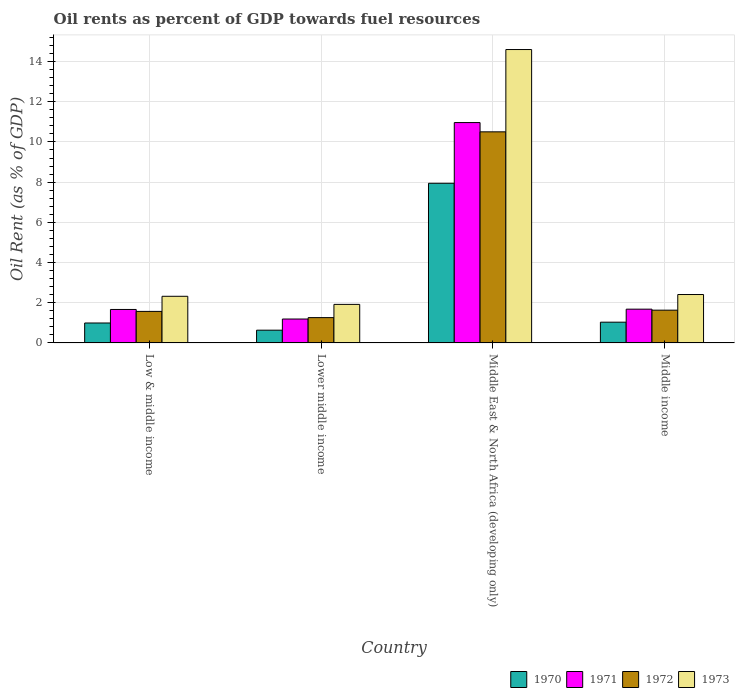How many different coloured bars are there?
Your response must be concise. 4. How many groups of bars are there?
Ensure brevity in your answer.  4. How many bars are there on the 4th tick from the left?
Provide a succinct answer. 4. What is the label of the 4th group of bars from the left?
Provide a short and direct response. Middle income. In how many cases, is the number of bars for a given country not equal to the number of legend labels?
Offer a very short reply. 0. What is the oil rent in 1972 in Lower middle income?
Provide a succinct answer. 1.26. Across all countries, what is the maximum oil rent in 1973?
Ensure brevity in your answer.  14.6. Across all countries, what is the minimum oil rent in 1973?
Ensure brevity in your answer.  1.92. In which country was the oil rent in 1973 maximum?
Your answer should be compact. Middle East & North Africa (developing only). In which country was the oil rent in 1971 minimum?
Offer a very short reply. Lower middle income. What is the total oil rent in 1971 in the graph?
Provide a short and direct response. 15.5. What is the difference between the oil rent in 1972 in Low & middle income and that in Middle East & North Africa (developing only)?
Ensure brevity in your answer.  -8.93. What is the difference between the oil rent in 1972 in Middle income and the oil rent in 1970 in Middle East & North Africa (developing only)?
Your response must be concise. -6.31. What is the average oil rent in 1973 per country?
Your answer should be very brief. 5.31. What is the difference between the oil rent of/in 1973 and oil rent of/in 1970 in Middle income?
Your answer should be very brief. 1.38. What is the ratio of the oil rent in 1970 in Lower middle income to that in Middle income?
Ensure brevity in your answer.  0.62. Is the oil rent in 1971 in Lower middle income less than that in Middle income?
Your answer should be very brief. Yes. Is the difference between the oil rent in 1973 in Lower middle income and Middle income greater than the difference between the oil rent in 1970 in Lower middle income and Middle income?
Offer a very short reply. No. What is the difference between the highest and the second highest oil rent in 1971?
Your response must be concise. -9.28. What is the difference between the highest and the lowest oil rent in 1973?
Offer a very short reply. 12.68. In how many countries, is the oil rent in 1973 greater than the average oil rent in 1973 taken over all countries?
Offer a terse response. 1. Is the sum of the oil rent in 1972 in Low & middle income and Middle income greater than the maximum oil rent in 1973 across all countries?
Give a very brief answer. No. What does the 4th bar from the right in Middle East & North Africa (developing only) represents?
Your answer should be compact. 1970. Is it the case that in every country, the sum of the oil rent in 1973 and oil rent in 1970 is greater than the oil rent in 1972?
Ensure brevity in your answer.  Yes. How many bars are there?
Make the answer very short. 16. What is the title of the graph?
Your answer should be very brief. Oil rents as percent of GDP towards fuel resources. Does "1963" appear as one of the legend labels in the graph?
Provide a succinct answer. No. What is the label or title of the X-axis?
Provide a short and direct response. Country. What is the label or title of the Y-axis?
Give a very brief answer. Oil Rent (as % of GDP). What is the Oil Rent (as % of GDP) of 1970 in Low & middle income?
Offer a very short reply. 0.99. What is the Oil Rent (as % of GDP) in 1971 in Low & middle income?
Keep it short and to the point. 1.67. What is the Oil Rent (as % of GDP) in 1972 in Low & middle income?
Your answer should be very brief. 1.57. What is the Oil Rent (as % of GDP) of 1973 in Low & middle income?
Offer a very short reply. 2.32. What is the Oil Rent (as % of GDP) of 1970 in Lower middle income?
Your answer should be compact. 0.63. What is the Oil Rent (as % of GDP) of 1971 in Lower middle income?
Your response must be concise. 1.19. What is the Oil Rent (as % of GDP) of 1972 in Lower middle income?
Keep it short and to the point. 1.26. What is the Oil Rent (as % of GDP) of 1973 in Lower middle income?
Your answer should be compact. 1.92. What is the Oil Rent (as % of GDP) in 1970 in Middle East & North Africa (developing only)?
Provide a short and direct response. 7.94. What is the Oil Rent (as % of GDP) of 1971 in Middle East & North Africa (developing only)?
Give a very brief answer. 10.96. What is the Oil Rent (as % of GDP) in 1972 in Middle East & North Africa (developing only)?
Your response must be concise. 10.5. What is the Oil Rent (as % of GDP) of 1973 in Middle East & North Africa (developing only)?
Your response must be concise. 14.6. What is the Oil Rent (as % of GDP) in 1970 in Middle income?
Ensure brevity in your answer.  1.03. What is the Oil Rent (as % of GDP) of 1971 in Middle income?
Give a very brief answer. 1.68. What is the Oil Rent (as % of GDP) of 1972 in Middle income?
Provide a short and direct response. 1.63. What is the Oil Rent (as % of GDP) in 1973 in Middle income?
Your response must be concise. 2.41. Across all countries, what is the maximum Oil Rent (as % of GDP) of 1970?
Provide a succinct answer. 7.94. Across all countries, what is the maximum Oil Rent (as % of GDP) in 1971?
Offer a very short reply. 10.96. Across all countries, what is the maximum Oil Rent (as % of GDP) of 1972?
Your response must be concise. 10.5. Across all countries, what is the maximum Oil Rent (as % of GDP) in 1973?
Your answer should be compact. 14.6. Across all countries, what is the minimum Oil Rent (as % of GDP) in 1970?
Offer a terse response. 0.63. Across all countries, what is the minimum Oil Rent (as % of GDP) in 1971?
Ensure brevity in your answer.  1.19. Across all countries, what is the minimum Oil Rent (as % of GDP) of 1972?
Your answer should be very brief. 1.26. Across all countries, what is the minimum Oil Rent (as % of GDP) of 1973?
Your response must be concise. 1.92. What is the total Oil Rent (as % of GDP) in 1970 in the graph?
Make the answer very short. 10.6. What is the total Oil Rent (as % of GDP) of 1971 in the graph?
Your answer should be very brief. 15.5. What is the total Oil Rent (as % of GDP) in 1972 in the graph?
Your response must be concise. 14.96. What is the total Oil Rent (as % of GDP) in 1973 in the graph?
Give a very brief answer. 21.24. What is the difference between the Oil Rent (as % of GDP) in 1970 in Low & middle income and that in Lower middle income?
Give a very brief answer. 0.36. What is the difference between the Oil Rent (as % of GDP) in 1971 in Low & middle income and that in Lower middle income?
Your answer should be compact. 0.48. What is the difference between the Oil Rent (as % of GDP) of 1972 in Low & middle income and that in Lower middle income?
Offer a very short reply. 0.31. What is the difference between the Oil Rent (as % of GDP) in 1973 in Low & middle income and that in Lower middle income?
Ensure brevity in your answer.  0.4. What is the difference between the Oil Rent (as % of GDP) in 1970 in Low & middle income and that in Middle East & North Africa (developing only)?
Provide a succinct answer. -6.95. What is the difference between the Oil Rent (as % of GDP) in 1971 in Low & middle income and that in Middle East & North Africa (developing only)?
Your answer should be very brief. -9.3. What is the difference between the Oil Rent (as % of GDP) of 1972 in Low & middle income and that in Middle East & North Africa (developing only)?
Your answer should be compact. -8.93. What is the difference between the Oil Rent (as % of GDP) of 1973 in Low & middle income and that in Middle East & North Africa (developing only)?
Offer a very short reply. -12.28. What is the difference between the Oil Rent (as % of GDP) in 1970 in Low & middle income and that in Middle income?
Keep it short and to the point. -0.04. What is the difference between the Oil Rent (as % of GDP) of 1971 in Low & middle income and that in Middle income?
Your answer should be very brief. -0.01. What is the difference between the Oil Rent (as % of GDP) of 1972 in Low & middle income and that in Middle income?
Your answer should be compact. -0.06. What is the difference between the Oil Rent (as % of GDP) of 1973 in Low & middle income and that in Middle income?
Keep it short and to the point. -0.09. What is the difference between the Oil Rent (as % of GDP) in 1970 in Lower middle income and that in Middle East & North Africa (developing only)?
Provide a short and direct response. -7.31. What is the difference between the Oil Rent (as % of GDP) of 1971 in Lower middle income and that in Middle East & North Africa (developing only)?
Ensure brevity in your answer.  -9.77. What is the difference between the Oil Rent (as % of GDP) of 1972 in Lower middle income and that in Middle East & North Africa (developing only)?
Your answer should be very brief. -9.24. What is the difference between the Oil Rent (as % of GDP) in 1973 in Lower middle income and that in Middle East & North Africa (developing only)?
Give a very brief answer. -12.68. What is the difference between the Oil Rent (as % of GDP) of 1970 in Lower middle income and that in Middle income?
Your response must be concise. -0.4. What is the difference between the Oil Rent (as % of GDP) of 1971 in Lower middle income and that in Middle income?
Your response must be concise. -0.49. What is the difference between the Oil Rent (as % of GDP) of 1972 in Lower middle income and that in Middle income?
Your answer should be compact. -0.37. What is the difference between the Oil Rent (as % of GDP) of 1973 in Lower middle income and that in Middle income?
Make the answer very short. -0.49. What is the difference between the Oil Rent (as % of GDP) in 1970 in Middle East & North Africa (developing only) and that in Middle income?
Make the answer very short. 6.91. What is the difference between the Oil Rent (as % of GDP) in 1971 in Middle East & North Africa (developing only) and that in Middle income?
Make the answer very short. 9.28. What is the difference between the Oil Rent (as % of GDP) in 1972 in Middle East & North Africa (developing only) and that in Middle income?
Keep it short and to the point. 8.87. What is the difference between the Oil Rent (as % of GDP) in 1973 in Middle East & North Africa (developing only) and that in Middle income?
Give a very brief answer. 12.19. What is the difference between the Oil Rent (as % of GDP) of 1970 in Low & middle income and the Oil Rent (as % of GDP) of 1971 in Lower middle income?
Ensure brevity in your answer.  -0.2. What is the difference between the Oil Rent (as % of GDP) of 1970 in Low & middle income and the Oil Rent (as % of GDP) of 1972 in Lower middle income?
Your answer should be compact. -0.27. What is the difference between the Oil Rent (as % of GDP) in 1970 in Low & middle income and the Oil Rent (as % of GDP) in 1973 in Lower middle income?
Offer a terse response. -0.93. What is the difference between the Oil Rent (as % of GDP) in 1971 in Low & middle income and the Oil Rent (as % of GDP) in 1972 in Lower middle income?
Your response must be concise. 0.41. What is the difference between the Oil Rent (as % of GDP) in 1971 in Low & middle income and the Oil Rent (as % of GDP) in 1973 in Lower middle income?
Make the answer very short. -0.25. What is the difference between the Oil Rent (as % of GDP) of 1972 in Low & middle income and the Oil Rent (as % of GDP) of 1973 in Lower middle income?
Your response must be concise. -0.35. What is the difference between the Oil Rent (as % of GDP) in 1970 in Low & middle income and the Oil Rent (as % of GDP) in 1971 in Middle East & North Africa (developing only)?
Your answer should be very brief. -9.97. What is the difference between the Oil Rent (as % of GDP) of 1970 in Low & middle income and the Oil Rent (as % of GDP) of 1972 in Middle East & North Africa (developing only)?
Offer a terse response. -9.51. What is the difference between the Oil Rent (as % of GDP) of 1970 in Low & middle income and the Oil Rent (as % of GDP) of 1973 in Middle East & North Africa (developing only)?
Your answer should be compact. -13.6. What is the difference between the Oil Rent (as % of GDP) of 1971 in Low & middle income and the Oil Rent (as % of GDP) of 1972 in Middle East & North Africa (developing only)?
Make the answer very short. -8.84. What is the difference between the Oil Rent (as % of GDP) of 1971 in Low & middle income and the Oil Rent (as % of GDP) of 1973 in Middle East & North Africa (developing only)?
Give a very brief answer. -12.93. What is the difference between the Oil Rent (as % of GDP) of 1972 in Low & middle income and the Oil Rent (as % of GDP) of 1973 in Middle East & North Africa (developing only)?
Your answer should be very brief. -13.03. What is the difference between the Oil Rent (as % of GDP) in 1970 in Low & middle income and the Oil Rent (as % of GDP) in 1971 in Middle income?
Ensure brevity in your answer.  -0.69. What is the difference between the Oil Rent (as % of GDP) of 1970 in Low & middle income and the Oil Rent (as % of GDP) of 1972 in Middle income?
Give a very brief answer. -0.64. What is the difference between the Oil Rent (as % of GDP) in 1970 in Low & middle income and the Oil Rent (as % of GDP) in 1973 in Middle income?
Your answer should be compact. -1.42. What is the difference between the Oil Rent (as % of GDP) of 1971 in Low & middle income and the Oil Rent (as % of GDP) of 1972 in Middle income?
Provide a short and direct response. 0.03. What is the difference between the Oil Rent (as % of GDP) of 1971 in Low & middle income and the Oil Rent (as % of GDP) of 1973 in Middle income?
Offer a terse response. -0.74. What is the difference between the Oil Rent (as % of GDP) in 1972 in Low & middle income and the Oil Rent (as % of GDP) in 1973 in Middle income?
Offer a very short reply. -0.84. What is the difference between the Oil Rent (as % of GDP) of 1970 in Lower middle income and the Oil Rent (as % of GDP) of 1971 in Middle East & North Africa (developing only)?
Ensure brevity in your answer.  -10.33. What is the difference between the Oil Rent (as % of GDP) in 1970 in Lower middle income and the Oil Rent (as % of GDP) in 1972 in Middle East & North Africa (developing only)?
Ensure brevity in your answer.  -9.87. What is the difference between the Oil Rent (as % of GDP) in 1970 in Lower middle income and the Oil Rent (as % of GDP) in 1973 in Middle East & North Africa (developing only)?
Give a very brief answer. -13.96. What is the difference between the Oil Rent (as % of GDP) of 1971 in Lower middle income and the Oil Rent (as % of GDP) of 1972 in Middle East & North Africa (developing only)?
Give a very brief answer. -9.31. What is the difference between the Oil Rent (as % of GDP) of 1971 in Lower middle income and the Oil Rent (as % of GDP) of 1973 in Middle East & North Africa (developing only)?
Give a very brief answer. -13.41. What is the difference between the Oil Rent (as % of GDP) of 1972 in Lower middle income and the Oil Rent (as % of GDP) of 1973 in Middle East & North Africa (developing only)?
Ensure brevity in your answer.  -13.34. What is the difference between the Oil Rent (as % of GDP) in 1970 in Lower middle income and the Oil Rent (as % of GDP) in 1971 in Middle income?
Ensure brevity in your answer.  -1.05. What is the difference between the Oil Rent (as % of GDP) in 1970 in Lower middle income and the Oil Rent (as % of GDP) in 1972 in Middle income?
Your response must be concise. -1. What is the difference between the Oil Rent (as % of GDP) in 1970 in Lower middle income and the Oil Rent (as % of GDP) in 1973 in Middle income?
Provide a succinct answer. -1.77. What is the difference between the Oil Rent (as % of GDP) in 1971 in Lower middle income and the Oil Rent (as % of GDP) in 1972 in Middle income?
Ensure brevity in your answer.  -0.44. What is the difference between the Oil Rent (as % of GDP) in 1971 in Lower middle income and the Oil Rent (as % of GDP) in 1973 in Middle income?
Offer a terse response. -1.22. What is the difference between the Oil Rent (as % of GDP) of 1972 in Lower middle income and the Oil Rent (as % of GDP) of 1973 in Middle income?
Your response must be concise. -1.15. What is the difference between the Oil Rent (as % of GDP) of 1970 in Middle East & North Africa (developing only) and the Oil Rent (as % of GDP) of 1971 in Middle income?
Your answer should be very brief. 6.26. What is the difference between the Oil Rent (as % of GDP) of 1970 in Middle East & North Africa (developing only) and the Oil Rent (as % of GDP) of 1972 in Middle income?
Offer a terse response. 6.31. What is the difference between the Oil Rent (as % of GDP) in 1970 in Middle East & North Africa (developing only) and the Oil Rent (as % of GDP) in 1973 in Middle income?
Offer a terse response. 5.53. What is the difference between the Oil Rent (as % of GDP) of 1971 in Middle East & North Africa (developing only) and the Oil Rent (as % of GDP) of 1972 in Middle income?
Offer a terse response. 9.33. What is the difference between the Oil Rent (as % of GDP) in 1971 in Middle East & North Africa (developing only) and the Oil Rent (as % of GDP) in 1973 in Middle income?
Your response must be concise. 8.55. What is the difference between the Oil Rent (as % of GDP) of 1972 in Middle East & North Africa (developing only) and the Oil Rent (as % of GDP) of 1973 in Middle income?
Ensure brevity in your answer.  8.09. What is the average Oil Rent (as % of GDP) of 1970 per country?
Offer a terse response. 2.65. What is the average Oil Rent (as % of GDP) of 1971 per country?
Offer a very short reply. 3.87. What is the average Oil Rent (as % of GDP) in 1972 per country?
Your answer should be compact. 3.74. What is the average Oil Rent (as % of GDP) in 1973 per country?
Make the answer very short. 5.31. What is the difference between the Oil Rent (as % of GDP) in 1970 and Oil Rent (as % of GDP) in 1971 in Low & middle income?
Provide a succinct answer. -0.67. What is the difference between the Oil Rent (as % of GDP) in 1970 and Oil Rent (as % of GDP) in 1972 in Low & middle income?
Keep it short and to the point. -0.58. What is the difference between the Oil Rent (as % of GDP) of 1970 and Oil Rent (as % of GDP) of 1973 in Low & middle income?
Your answer should be compact. -1.33. What is the difference between the Oil Rent (as % of GDP) in 1971 and Oil Rent (as % of GDP) in 1972 in Low & middle income?
Give a very brief answer. 0.1. What is the difference between the Oil Rent (as % of GDP) in 1971 and Oil Rent (as % of GDP) in 1973 in Low & middle income?
Your response must be concise. -0.66. What is the difference between the Oil Rent (as % of GDP) of 1972 and Oil Rent (as % of GDP) of 1973 in Low & middle income?
Ensure brevity in your answer.  -0.75. What is the difference between the Oil Rent (as % of GDP) in 1970 and Oil Rent (as % of GDP) in 1971 in Lower middle income?
Make the answer very short. -0.56. What is the difference between the Oil Rent (as % of GDP) in 1970 and Oil Rent (as % of GDP) in 1972 in Lower middle income?
Keep it short and to the point. -0.62. What is the difference between the Oil Rent (as % of GDP) of 1970 and Oil Rent (as % of GDP) of 1973 in Lower middle income?
Provide a short and direct response. -1.28. What is the difference between the Oil Rent (as % of GDP) of 1971 and Oil Rent (as % of GDP) of 1972 in Lower middle income?
Provide a short and direct response. -0.07. What is the difference between the Oil Rent (as % of GDP) in 1971 and Oil Rent (as % of GDP) in 1973 in Lower middle income?
Provide a short and direct response. -0.73. What is the difference between the Oil Rent (as % of GDP) in 1972 and Oil Rent (as % of GDP) in 1973 in Lower middle income?
Offer a very short reply. -0.66. What is the difference between the Oil Rent (as % of GDP) of 1970 and Oil Rent (as % of GDP) of 1971 in Middle East & North Africa (developing only)?
Give a very brief answer. -3.02. What is the difference between the Oil Rent (as % of GDP) in 1970 and Oil Rent (as % of GDP) in 1972 in Middle East & North Africa (developing only)?
Your answer should be very brief. -2.56. What is the difference between the Oil Rent (as % of GDP) in 1970 and Oil Rent (as % of GDP) in 1973 in Middle East & North Africa (developing only)?
Your answer should be very brief. -6.65. What is the difference between the Oil Rent (as % of GDP) in 1971 and Oil Rent (as % of GDP) in 1972 in Middle East & North Africa (developing only)?
Your answer should be compact. 0.46. What is the difference between the Oil Rent (as % of GDP) of 1971 and Oil Rent (as % of GDP) of 1973 in Middle East & North Africa (developing only)?
Your answer should be very brief. -3.63. What is the difference between the Oil Rent (as % of GDP) of 1972 and Oil Rent (as % of GDP) of 1973 in Middle East & North Africa (developing only)?
Your answer should be compact. -4.09. What is the difference between the Oil Rent (as % of GDP) in 1970 and Oil Rent (as % of GDP) in 1971 in Middle income?
Make the answer very short. -0.65. What is the difference between the Oil Rent (as % of GDP) of 1970 and Oil Rent (as % of GDP) of 1972 in Middle income?
Make the answer very short. -0.6. What is the difference between the Oil Rent (as % of GDP) in 1970 and Oil Rent (as % of GDP) in 1973 in Middle income?
Ensure brevity in your answer.  -1.38. What is the difference between the Oil Rent (as % of GDP) of 1971 and Oil Rent (as % of GDP) of 1972 in Middle income?
Offer a very short reply. 0.05. What is the difference between the Oil Rent (as % of GDP) in 1971 and Oil Rent (as % of GDP) in 1973 in Middle income?
Your response must be concise. -0.73. What is the difference between the Oil Rent (as % of GDP) in 1972 and Oil Rent (as % of GDP) in 1973 in Middle income?
Keep it short and to the point. -0.78. What is the ratio of the Oil Rent (as % of GDP) of 1970 in Low & middle income to that in Lower middle income?
Give a very brief answer. 1.56. What is the ratio of the Oil Rent (as % of GDP) in 1971 in Low & middle income to that in Lower middle income?
Keep it short and to the point. 1.4. What is the ratio of the Oil Rent (as % of GDP) of 1972 in Low & middle income to that in Lower middle income?
Provide a short and direct response. 1.25. What is the ratio of the Oil Rent (as % of GDP) in 1973 in Low & middle income to that in Lower middle income?
Ensure brevity in your answer.  1.21. What is the ratio of the Oil Rent (as % of GDP) in 1970 in Low & middle income to that in Middle East & North Africa (developing only)?
Offer a terse response. 0.12. What is the ratio of the Oil Rent (as % of GDP) in 1971 in Low & middle income to that in Middle East & North Africa (developing only)?
Offer a terse response. 0.15. What is the ratio of the Oil Rent (as % of GDP) in 1972 in Low & middle income to that in Middle East & North Africa (developing only)?
Your response must be concise. 0.15. What is the ratio of the Oil Rent (as % of GDP) in 1973 in Low & middle income to that in Middle East & North Africa (developing only)?
Your answer should be very brief. 0.16. What is the ratio of the Oil Rent (as % of GDP) in 1971 in Low & middle income to that in Middle income?
Give a very brief answer. 0.99. What is the ratio of the Oil Rent (as % of GDP) of 1972 in Low & middle income to that in Middle income?
Your answer should be very brief. 0.96. What is the ratio of the Oil Rent (as % of GDP) of 1973 in Low & middle income to that in Middle income?
Keep it short and to the point. 0.96. What is the ratio of the Oil Rent (as % of GDP) in 1970 in Lower middle income to that in Middle East & North Africa (developing only)?
Provide a short and direct response. 0.08. What is the ratio of the Oil Rent (as % of GDP) in 1971 in Lower middle income to that in Middle East & North Africa (developing only)?
Your response must be concise. 0.11. What is the ratio of the Oil Rent (as % of GDP) in 1972 in Lower middle income to that in Middle East & North Africa (developing only)?
Make the answer very short. 0.12. What is the ratio of the Oil Rent (as % of GDP) in 1973 in Lower middle income to that in Middle East & North Africa (developing only)?
Ensure brevity in your answer.  0.13. What is the ratio of the Oil Rent (as % of GDP) in 1970 in Lower middle income to that in Middle income?
Offer a very short reply. 0.61. What is the ratio of the Oil Rent (as % of GDP) of 1971 in Lower middle income to that in Middle income?
Keep it short and to the point. 0.71. What is the ratio of the Oil Rent (as % of GDP) of 1972 in Lower middle income to that in Middle income?
Your response must be concise. 0.77. What is the ratio of the Oil Rent (as % of GDP) of 1973 in Lower middle income to that in Middle income?
Provide a succinct answer. 0.8. What is the ratio of the Oil Rent (as % of GDP) of 1970 in Middle East & North Africa (developing only) to that in Middle income?
Offer a terse response. 7.69. What is the ratio of the Oil Rent (as % of GDP) in 1971 in Middle East & North Africa (developing only) to that in Middle income?
Offer a terse response. 6.52. What is the ratio of the Oil Rent (as % of GDP) of 1972 in Middle East & North Africa (developing only) to that in Middle income?
Give a very brief answer. 6.44. What is the ratio of the Oil Rent (as % of GDP) of 1973 in Middle East & North Africa (developing only) to that in Middle income?
Provide a succinct answer. 6.06. What is the difference between the highest and the second highest Oil Rent (as % of GDP) in 1970?
Make the answer very short. 6.91. What is the difference between the highest and the second highest Oil Rent (as % of GDP) in 1971?
Your answer should be compact. 9.28. What is the difference between the highest and the second highest Oil Rent (as % of GDP) of 1972?
Your answer should be very brief. 8.87. What is the difference between the highest and the second highest Oil Rent (as % of GDP) of 1973?
Your answer should be very brief. 12.19. What is the difference between the highest and the lowest Oil Rent (as % of GDP) in 1970?
Your response must be concise. 7.31. What is the difference between the highest and the lowest Oil Rent (as % of GDP) in 1971?
Provide a succinct answer. 9.77. What is the difference between the highest and the lowest Oil Rent (as % of GDP) of 1972?
Make the answer very short. 9.24. What is the difference between the highest and the lowest Oil Rent (as % of GDP) of 1973?
Make the answer very short. 12.68. 